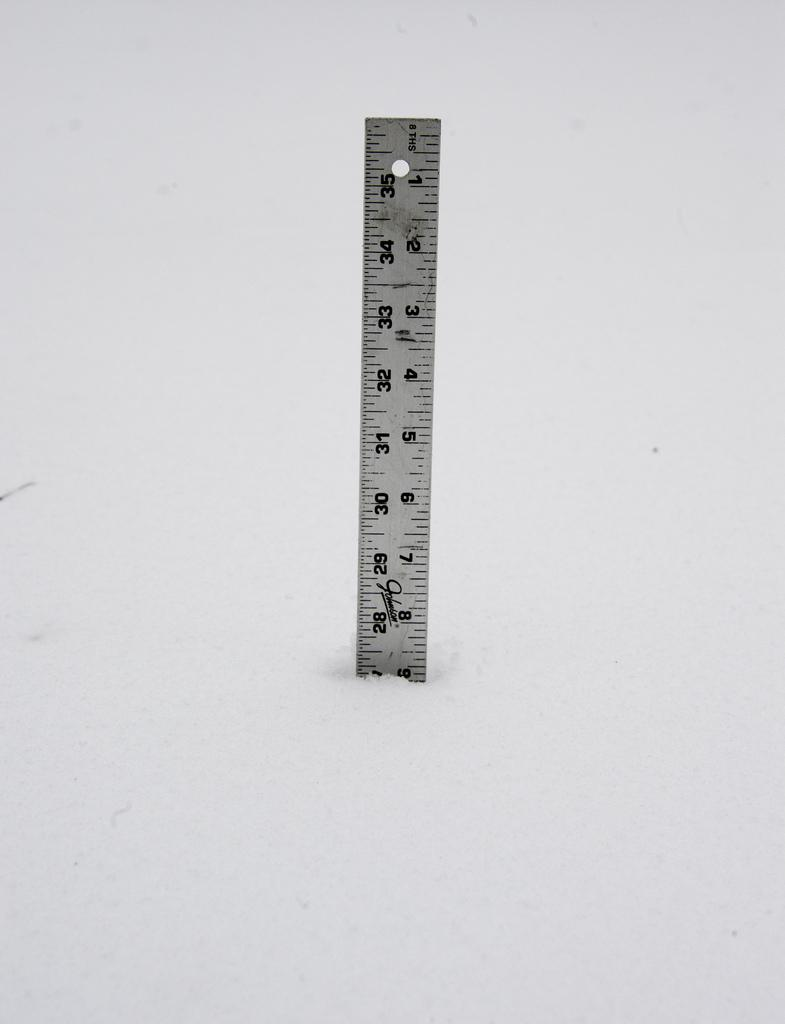Provide a one-sentence caption for the provided image. The ruler shown has been broken at 9 inches. 